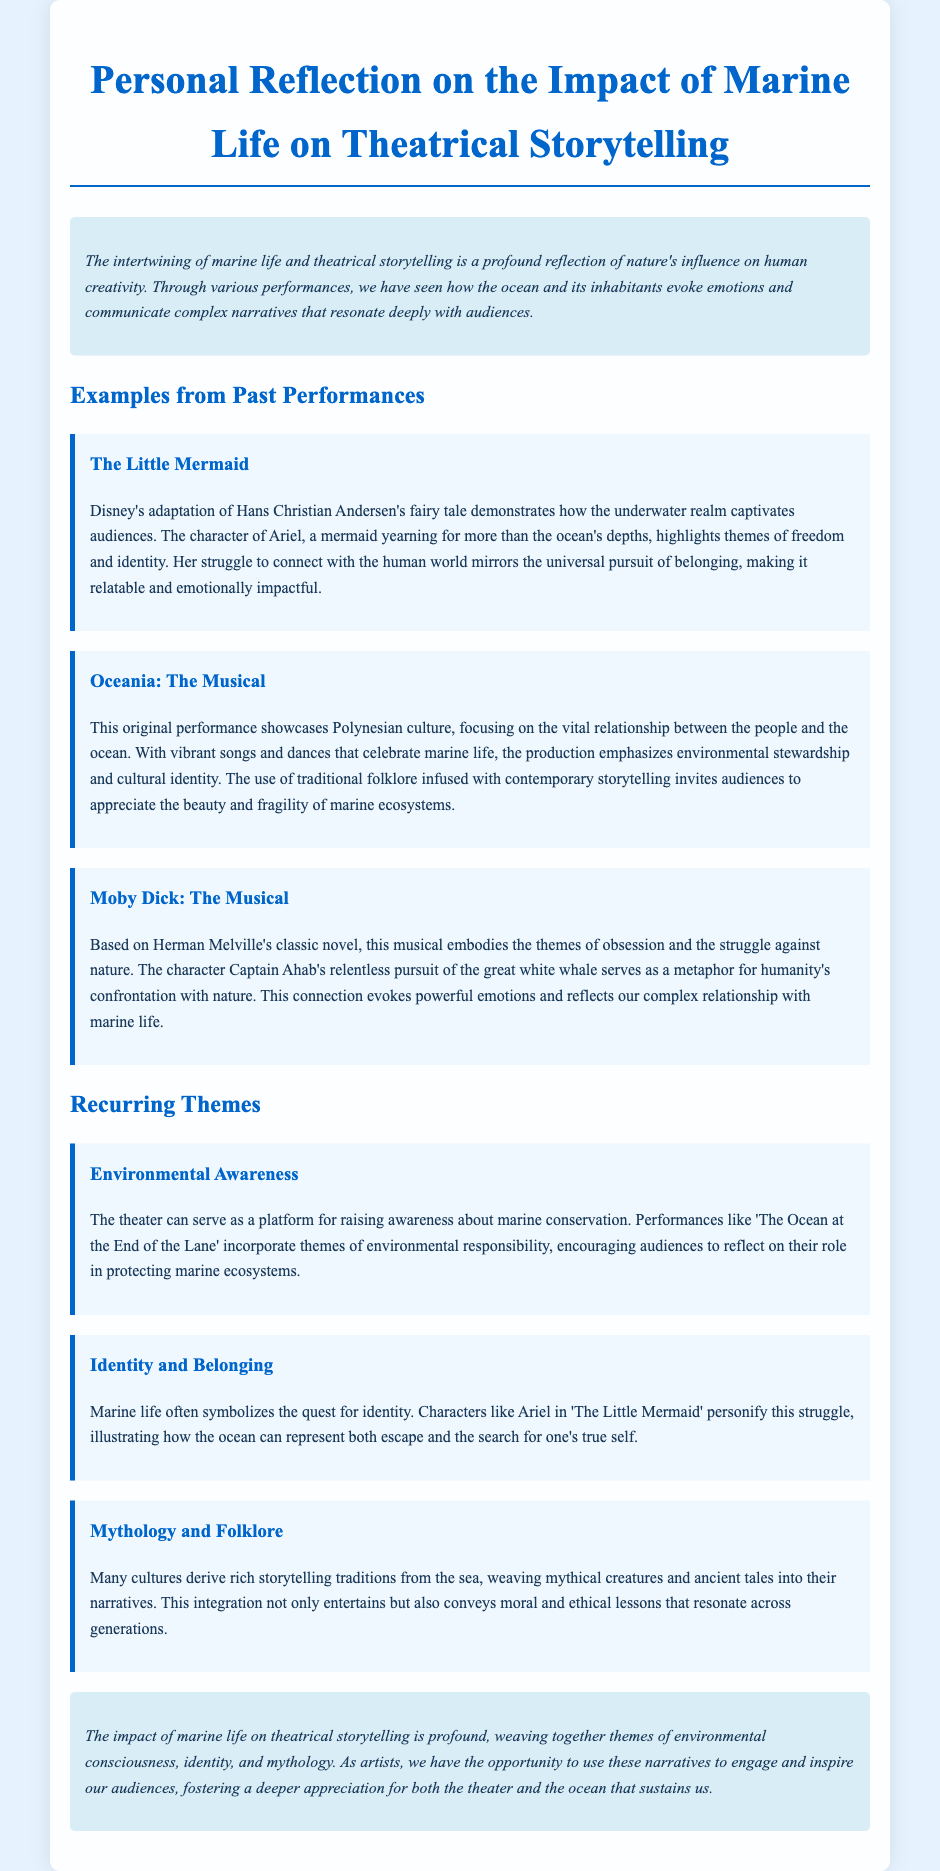What is the title of the reflection note? The title is found at the top of the document, which describes the content of the note.
Answer: Personal Reflection on the Impact of Marine Life on Theatrical Storytelling Who is the main character in Disney's adaptation mentioned? The main character is explicitly stated in the section discussing "The Little Mermaid."
Answer: Ariel What does "Oceania: The Musical" focus on? The focus is stated in relation to the culture highlighted in "Oceania: The Musical."
Answer: Polynesian culture What theme is associated with "The Little Mermaid"? The theme is derived from the discussion about the character's journey within the performance.
Answer: Freedom and identity Which musical is based on Herman Melville's novel? The specific musical is mentioned in the section discussing its relationship to literature.
Answer: Moby Dick: The Musical What recurring theme involves responsibility for marine ecosystems? The theme is identified in the section describing performances related to environmental issues.
Answer: Environmental Awareness How does the ocean symbolize identity in the document? The document explains this concept in relation to characters and their struggles.
Answer: Quest for identity What ancient element does the document say many cultures derive from the sea? This element is highlighted in the section discussing cultural narratives and storytelling.
Answer: Mythology and Folklore 